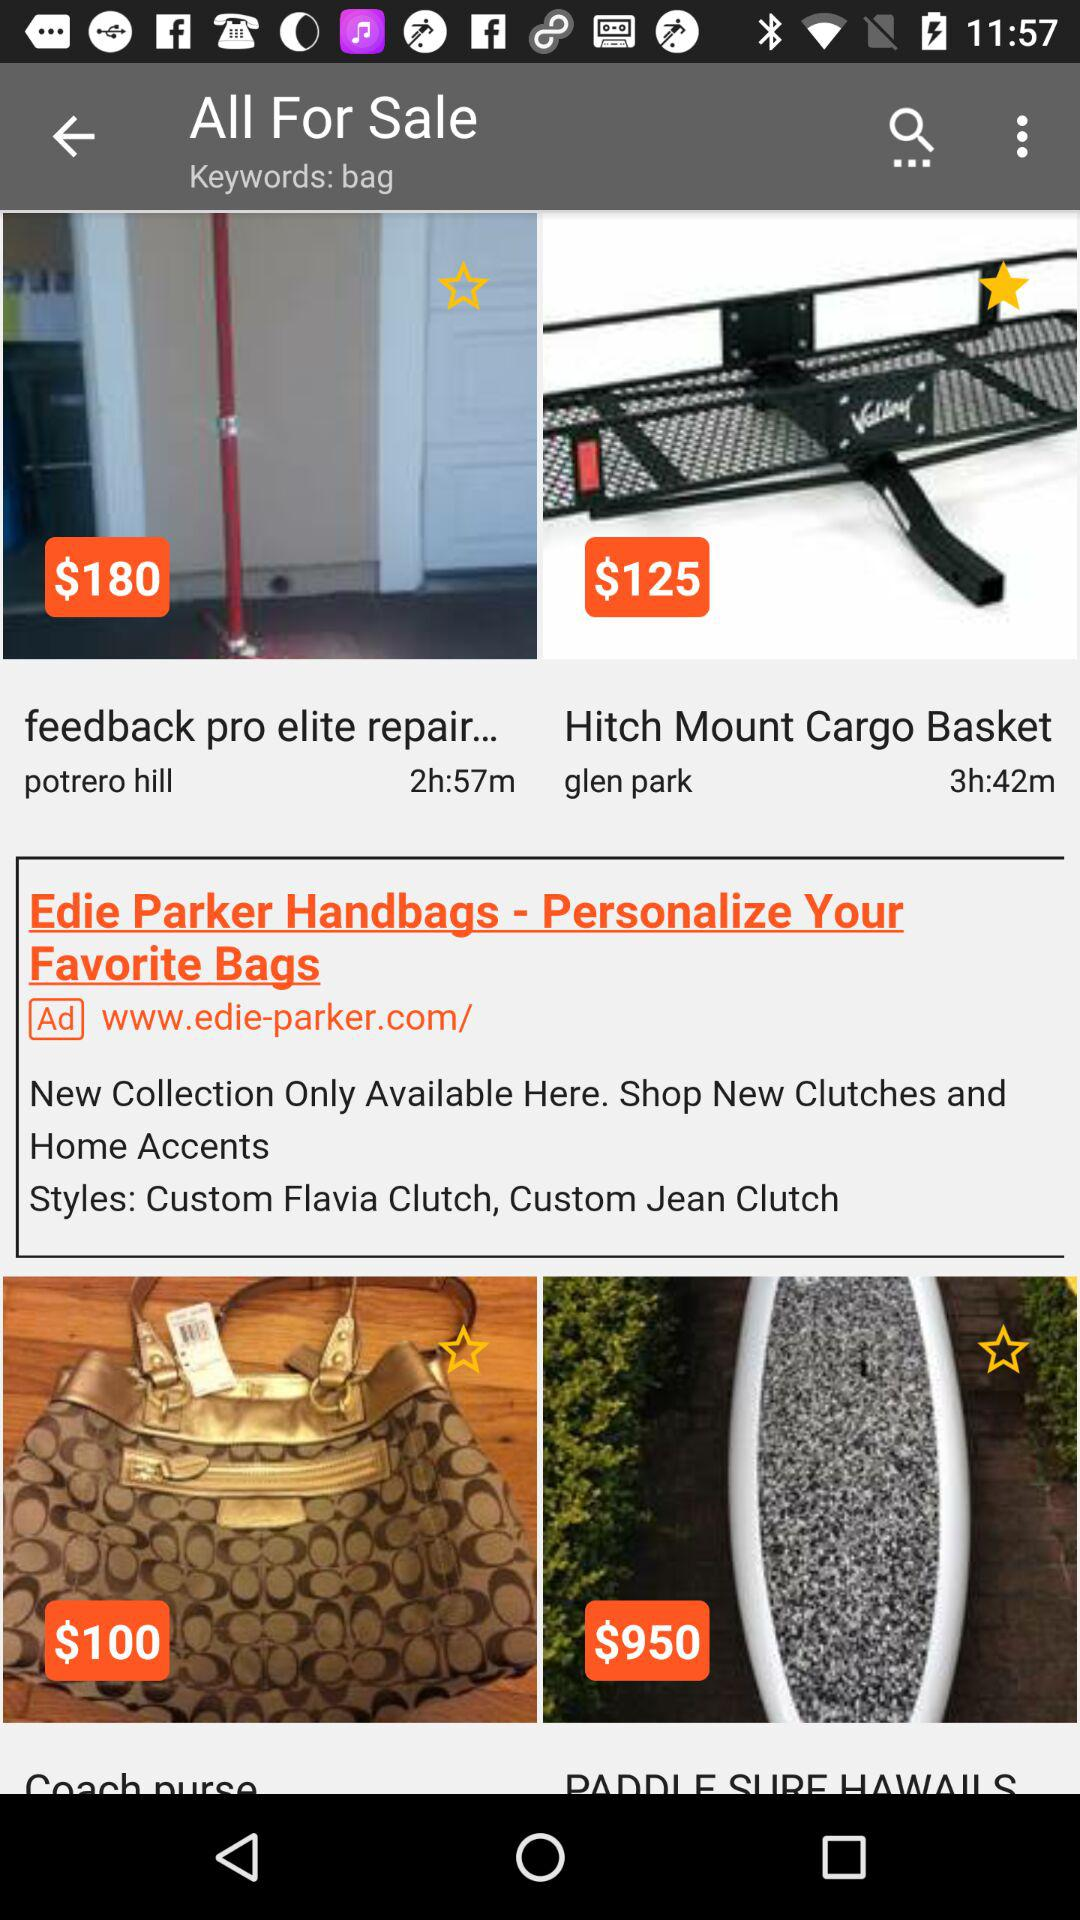What is the price of a Feedback Pro Elite repair? The price is $180. 